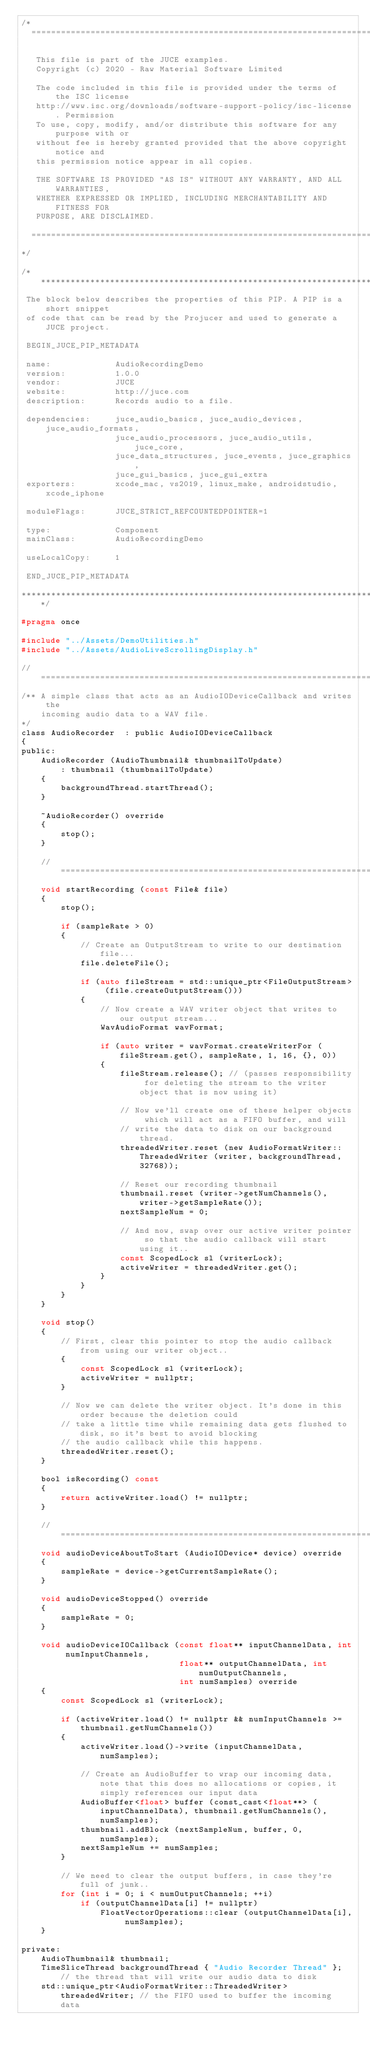Convert code to text. <code><loc_0><loc_0><loc_500><loc_500><_C_>/*
  ==============================================================================

   This file is part of the JUCE examples.
   Copyright (c) 2020 - Raw Material Software Limited

   The code included in this file is provided under the terms of the ISC license
   http://www.isc.org/downloads/software-support-policy/isc-license. Permission
   To use, copy, modify, and/or distribute this software for any purpose with or
   without fee is hereby granted provided that the above copyright notice and
   this permission notice appear in all copies.

   THE SOFTWARE IS PROVIDED "AS IS" WITHOUT ANY WARRANTY, AND ALL WARRANTIES,
   WHETHER EXPRESSED OR IMPLIED, INCLUDING MERCHANTABILITY AND FITNESS FOR
   PURPOSE, ARE DISCLAIMED.

  ==============================================================================
*/

/*******************************************************************************
 The block below describes the properties of this PIP. A PIP is a short snippet
 of code that can be read by the Projucer and used to generate a JUCE project.

 BEGIN_JUCE_PIP_METADATA

 name:             AudioRecordingDemo
 version:          1.0.0
 vendor:           JUCE
 website:          http://juce.com
 description:      Records audio to a file.

 dependencies:     juce_audio_basics, juce_audio_devices, juce_audio_formats,
                   juce_audio_processors, juce_audio_utils, juce_core,
                   juce_data_structures, juce_events, juce_graphics,
                   juce_gui_basics, juce_gui_extra
 exporters:        xcode_mac, vs2019, linux_make, androidstudio, xcode_iphone

 moduleFlags:      JUCE_STRICT_REFCOUNTEDPOINTER=1

 type:             Component
 mainClass:        AudioRecordingDemo

 useLocalCopy:     1

 END_JUCE_PIP_METADATA

*******************************************************************************/

#pragma once

#include "../Assets/DemoUtilities.h"
#include "../Assets/AudioLiveScrollingDisplay.h"

//==============================================================================
/** A simple class that acts as an AudioIODeviceCallback and writes the
    incoming audio data to a WAV file.
*/
class AudioRecorder  : public AudioIODeviceCallback
{
public:
    AudioRecorder (AudioThumbnail& thumbnailToUpdate)
        : thumbnail (thumbnailToUpdate)
    {
        backgroundThread.startThread();
    }

    ~AudioRecorder() override
    {
        stop();
    }

    //==============================================================================
    void startRecording (const File& file)
    {
        stop();

        if (sampleRate > 0)
        {
            // Create an OutputStream to write to our destination file...
            file.deleteFile();

            if (auto fileStream = std::unique_ptr<FileOutputStream> (file.createOutputStream()))
            {
                // Now create a WAV writer object that writes to our output stream...
                WavAudioFormat wavFormat;

                if (auto writer = wavFormat.createWriterFor (fileStream.get(), sampleRate, 1, 16, {}, 0))
                {
                    fileStream.release(); // (passes responsibility for deleting the stream to the writer object that is now using it)

                    // Now we'll create one of these helper objects which will act as a FIFO buffer, and will
                    // write the data to disk on our background thread.
                    threadedWriter.reset (new AudioFormatWriter::ThreadedWriter (writer, backgroundThread, 32768));

                    // Reset our recording thumbnail
                    thumbnail.reset (writer->getNumChannels(), writer->getSampleRate());
                    nextSampleNum = 0;

                    // And now, swap over our active writer pointer so that the audio callback will start using it..
                    const ScopedLock sl (writerLock);
                    activeWriter = threadedWriter.get();
                }
            }
        }
    }

    void stop()
    {
        // First, clear this pointer to stop the audio callback from using our writer object..
        {
            const ScopedLock sl (writerLock);
            activeWriter = nullptr;
        }

        // Now we can delete the writer object. It's done in this order because the deletion could
        // take a little time while remaining data gets flushed to disk, so it's best to avoid blocking
        // the audio callback while this happens.
        threadedWriter.reset();
    }

    bool isRecording() const
    {
        return activeWriter.load() != nullptr;
    }

    //==============================================================================
    void audioDeviceAboutToStart (AudioIODevice* device) override
    {
        sampleRate = device->getCurrentSampleRate();
    }

    void audioDeviceStopped() override
    {
        sampleRate = 0;
    }

    void audioDeviceIOCallback (const float** inputChannelData, int numInputChannels,
                                float** outputChannelData, int numOutputChannels,
                                int numSamples) override
    {
        const ScopedLock sl (writerLock);

        if (activeWriter.load() != nullptr && numInputChannels >= thumbnail.getNumChannels())
        {
            activeWriter.load()->write (inputChannelData, numSamples);

            // Create an AudioBuffer to wrap our incoming data, note that this does no allocations or copies, it simply references our input data
            AudioBuffer<float> buffer (const_cast<float**> (inputChannelData), thumbnail.getNumChannels(), numSamples);
            thumbnail.addBlock (nextSampleNum, buffer, 0, numSamples);
            nextSampleNum += numSamples;
        }

        // We need to clear the output buffers, in case they're full of junk..
        for (int i = 0; i < numOutputChannels; ++i)
            if (outputChannelData[i] != nullptr)
                FloatVectorOperations::clear (outputChannelData[i], numSamples);
    }

private:
    AudioThumbnail& thumbnail;
    TimeSliceThread backgroundThread { "Audio Recorder Thread" }; // the thread that will write our audio data to disk
    std::unique_ptr<AudioFormatWriter::ThreadedWriter> threadedWriter; // the FIFO used to buffer the incoming data</code> 